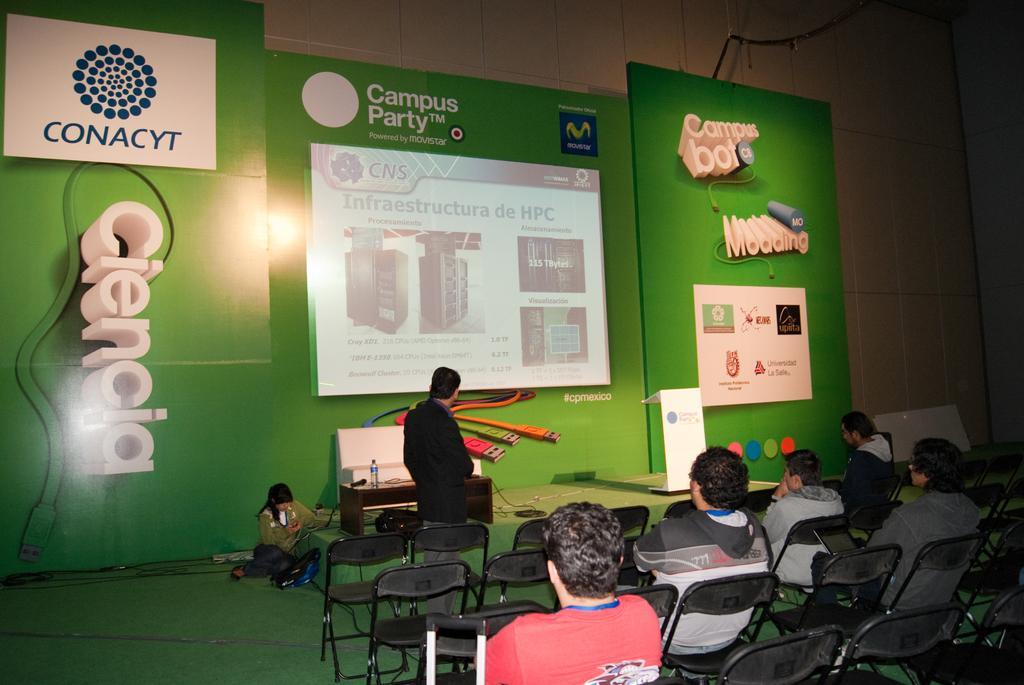Could you give a brief overview of what you see in this image? In this image there is a person standing in front of the dais, beside him on the chairs there are a few people sitting, behind him on the dais there are some objects, beside the dais there is a person seated on the floor, in the background of the image there is a screen and banners on the wall. 